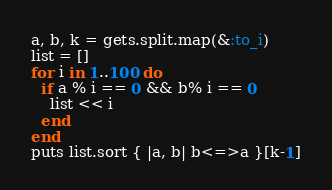Convert code to text. <code><loc_0><loc_0><loc_500><loc_500><_Ruby_>a, b, k = gets.split.map(&:to_i)
list = []
for i in 1..100 do
  if a % i == 0 && b% i == 0
    list << i
  end
end
puts list.sort { |a, b| b<=>a }[k-1]</code> 